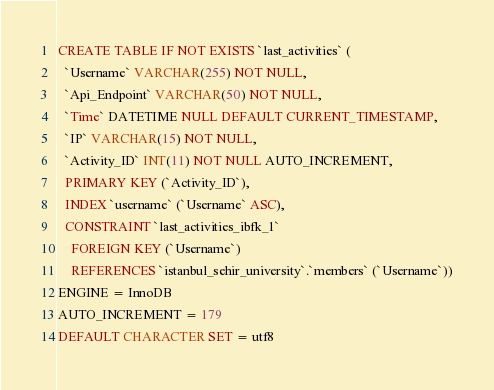Convert code to text. <code><loc_0><loc_0><loc_500><loc_500><_SQL_>CREATE TABLE IF NOT EXISTS `last_activities` (
  `Username` VARCHAR(255) NOT NULL,
  `Api_Endpoint` VARCHAR(50) NOT NULL,
  `Time` DATETIME NULL DEFAULT CURRENT_TIMESTAMP,
  `IP` VARCHAR(15) NOT NULL,
  `Activity_ID` INT(11) NOT NULL AUTO_INCREMENT,
  PRIMARY KEY (`Activity_ID`),
  INDEX `username` (`Username` ASC),
  CONSTRAINT `last_activities_ibfk_1`
    FOREIGN KEY (`Username`)
    REFERENCES `istanbul_sehir_university`.`members` (`Username`))
ENGINE = InnoDB
AUTO_INCREMENT = 179
DEFAULT CHARACTER SET = utf8</code> 